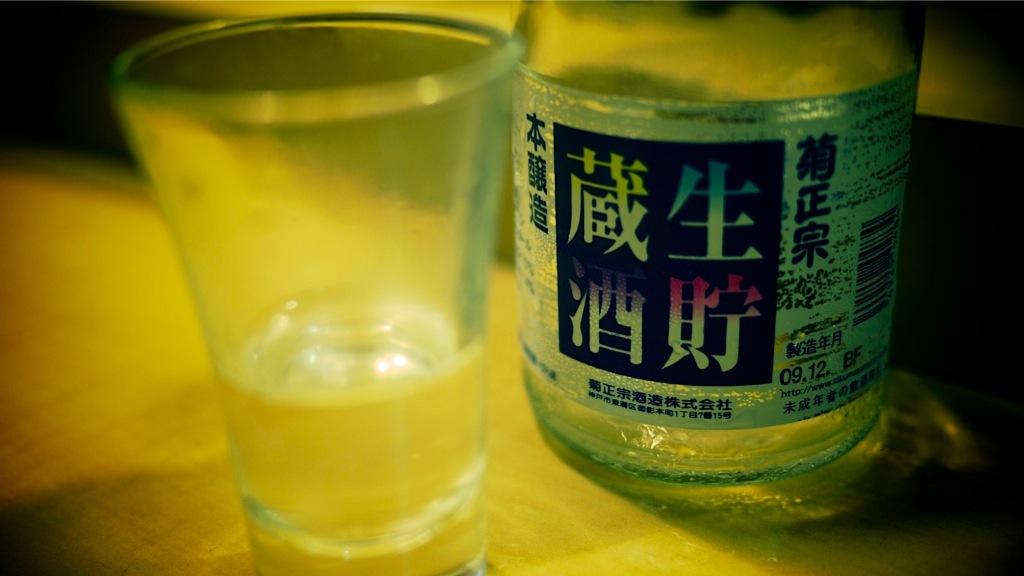What number is beside 09?
Give a very brief answer. 12. 